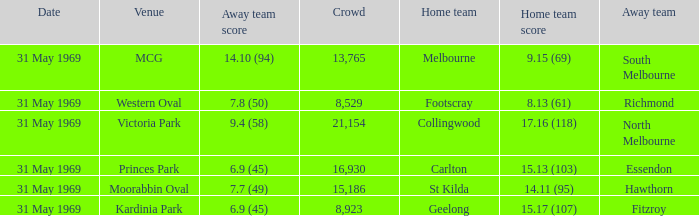Who was the home team that played in Victoria Park? Collingwood. 